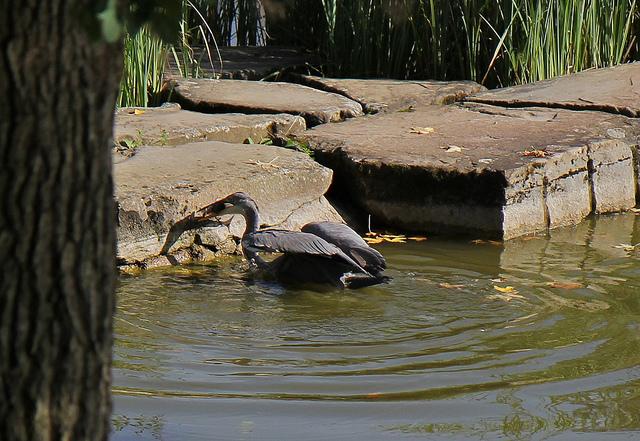What material is the wall made of?
Answer briefly. Concrete. Is this bird standing in the grass?
Write a very short answer. No. Is that dirty water?
Write a very short answer. Yes. What kind of bird is this?
Give a very brief answer. Pelican. Is that a bear?
Keep it brief. No. 